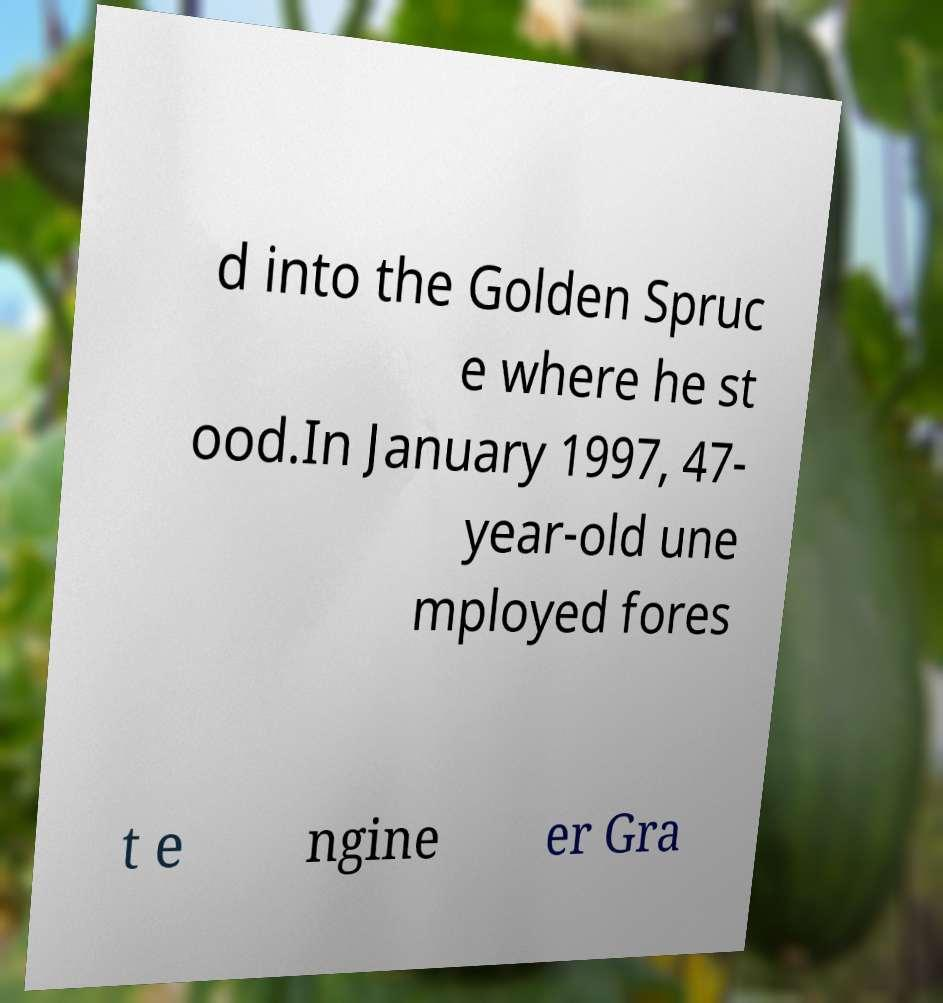Could you assist in decoding the text presented in this image and type it out clearly? d into the Golden Spruc e where he st ood.In January 1997, 47- year-old une mployed fores t e ngine er Gra 